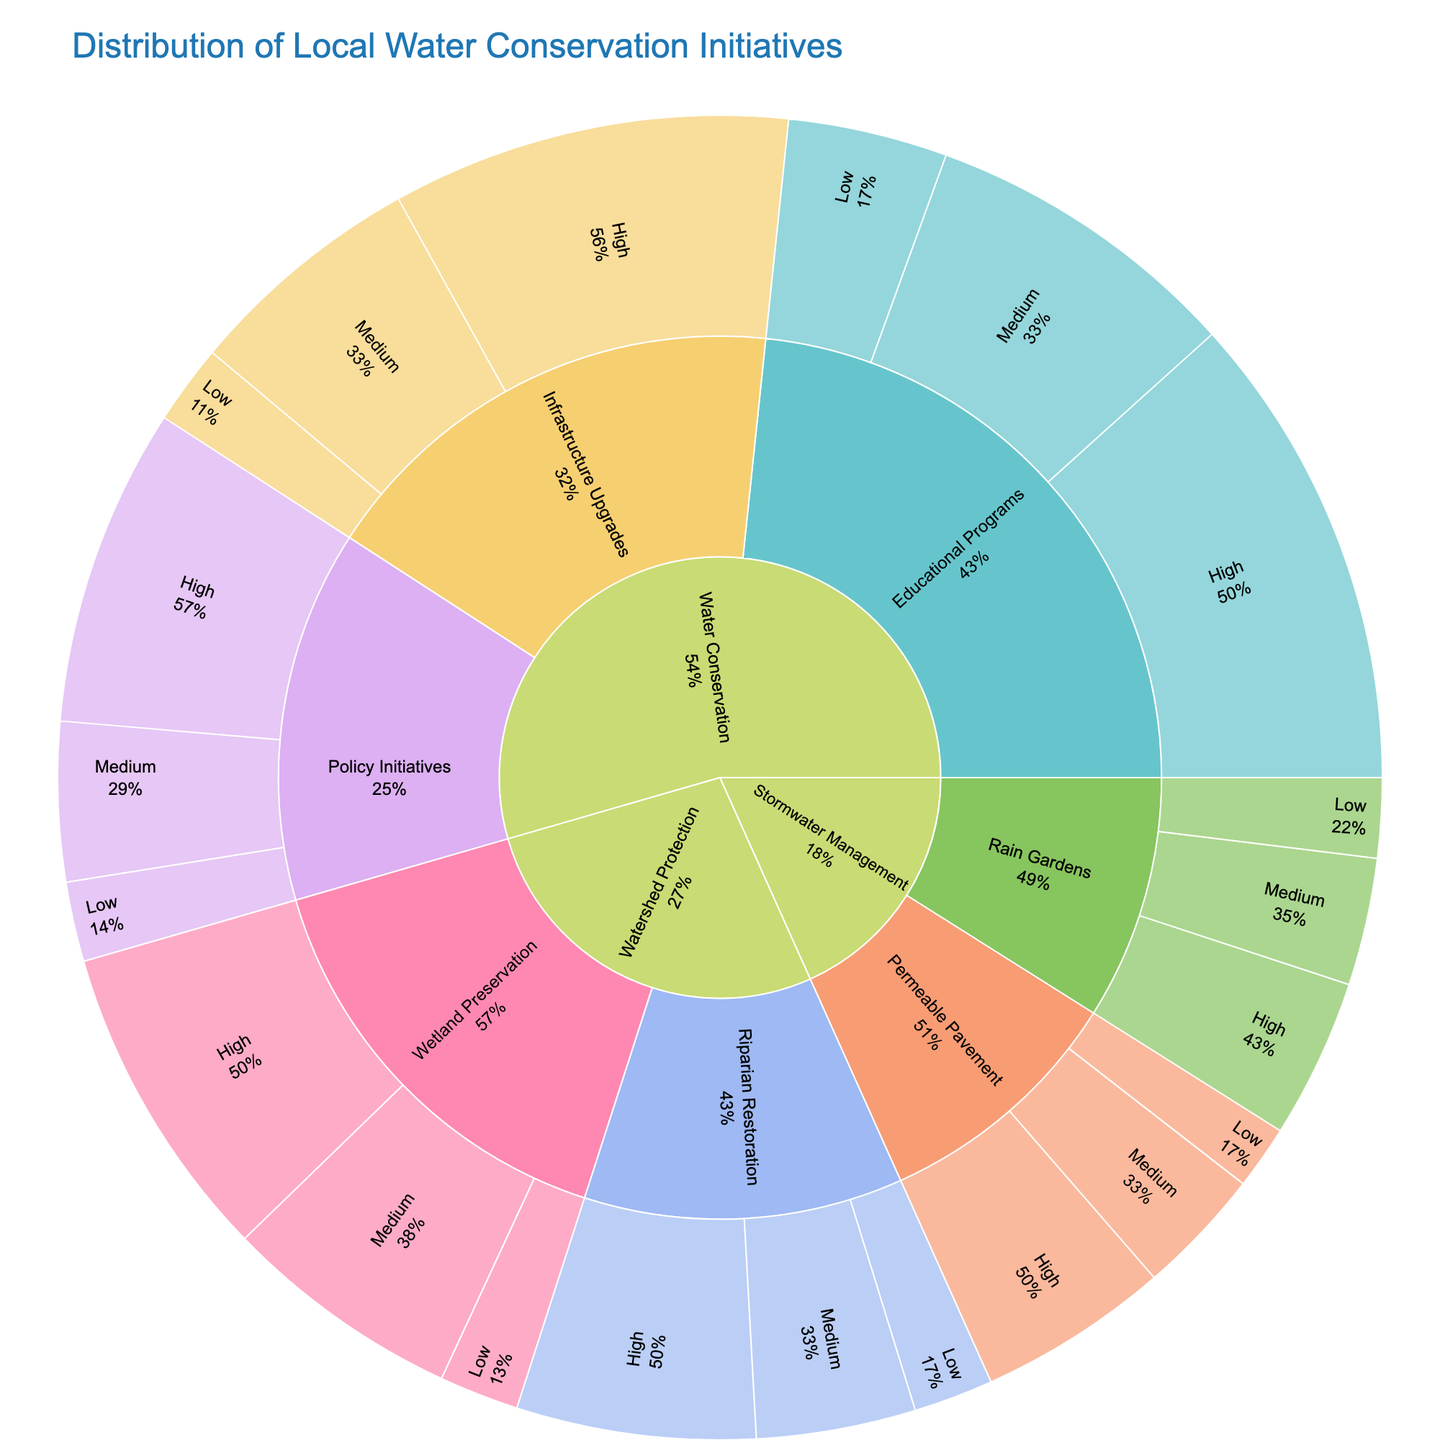What's the title of the sunburst plot? The title is usually found at the top of the plot, summarizing what the plot is about. In this case, it reads as "Distribution of Local Water Conservation Initiatives."
Answer: Distribution of Local Water Conservation Initiatives Which project type has the highest total impact value? By summing up the high, medium, and low impact values for each project type, you can determine the project with the highest total impact value. "Water Conservation" total = 130, "Watershed Protection" total = 70, and "Stormwater Management" total = 47.
Answer: Water Conservation How many categories of impact levels are shown in the plot? The categories of impact levels can be seen in each project type section towards the end. They are listed as "High," "Medium," and "Low." The count of these categories is three.
Answer: 3 Which "Watershed Protection" initiative has the highest impact value at the high level? Within the Watershed Protection section, look for the initiative with the highest value labeled "High." "Wetland Preservation" under Watershed Protection has a high impact value of 20.
Answer: Wetland Preservation Compare the value of high impact between "Educational Programs" and "Riparian Restoration." Which one is higher? By looking at the high impact value within the Educational Programs and Riparian Restoration sections, compare the values. "Educational Programs" has a value of 30, while "Riparian Restoration" has a value of 15.
Answer: Educational Programs What is the total impact value for "Infrastructure Upgrades" under Water Conservation? To find this total, sum the high, medium, and low impact values for "Infrastructure Upgrades" under Water Conservation. The values are 25, 15, and 5 respectively.
Answer: 45 What's the percentage distribution of high impact within "Stormwater Management" compared to its total value? For Stormwater Management's high impact value (10), calculate its percentage against the total Stormwater Management value (10+8+5+12+8+4 = 47). The percentage is (10/47) * 100%.
Answer: ~21.3% Which initiative under "Watershed Protection" has the lowest total impact value? Sum the high, medium, and low impact values for each initiative under "Watershed Protection". "Riparian Restoration" has total impact values of 15 (High) + 10 (Medium) + 5 (Low) = 30. "Wetland Preservation" has total impact values of 20 (High) + 15 (Medium) + 5 (Low) = 40.
Answer: Riparian Restoration What portion of the total value within "Water Conservation" does "Policy Initiatives" contribute? Sum the values in "Policy Initiatives" (20 for High, 10 for Medium, 5 for Low), resulting in 35. Then sum the total value in "Water Conservation" (30+20+10+25+15+5+20+10+5 = 140). The portion is 35/140.
Answer: ~25% 